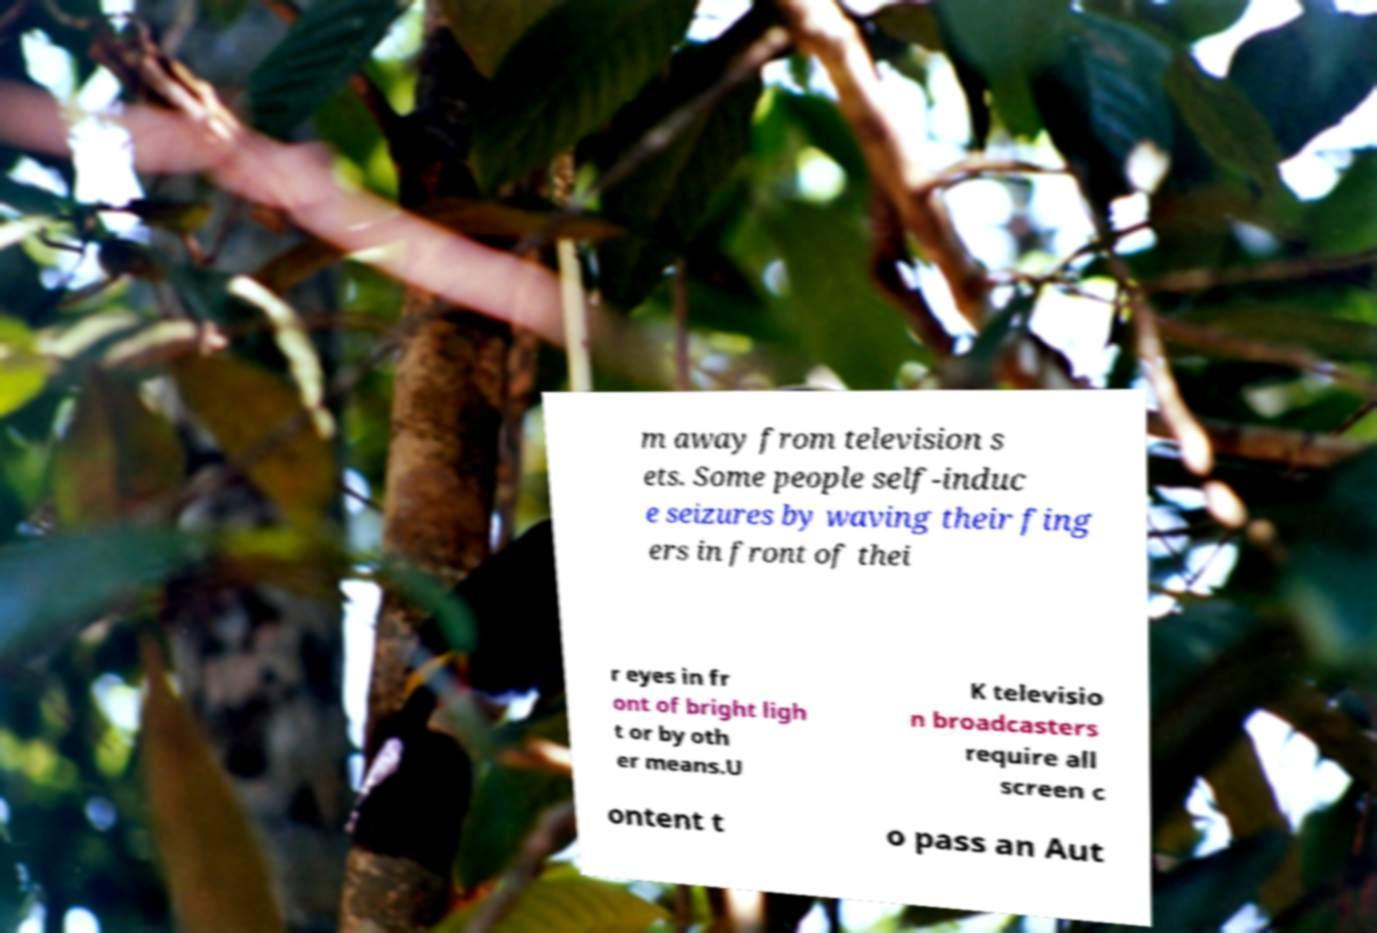There's text embedded in this image that I need extracted. Can you transcribe it verbatim? m away from television s ets. Some people self-induc e seizures by waving their fing ers in front of thei r eyes in fr ont of bright ligh t or by oth er means.U K televisio n broadcasters require all screen c ontent t o pass an Aut 